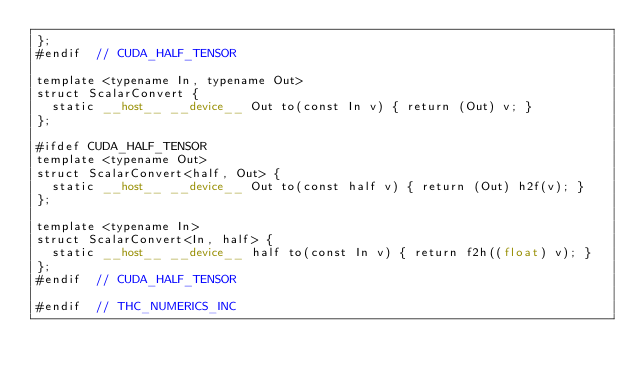<code> <loc_0><loc_0><loc_500><loc_500><_Cuda_>};
#endif  // CUDA_HALF_TENSOR

template <typename In, typename Out>
struct ScalarConvert {
  static __host__ __device__ Out to(const In v) { return (Out) v; }
};

#ifdef CUDA_HALF_TENSOR
template <typename Out>
struct ScalarConvert<half, Out> {
  static __host__ __device__ Out to(const half v) { return (Out) h2f(v); }
};

template <typename In>
struct ScalarConvert<In, half> {
  static __host__ __device__ half to(const In v) { return f2h((float) v); }
};
#endif  // CUDA_HALF_TENSOR

#endif  // THC_NUMERICS_INC
</code> 